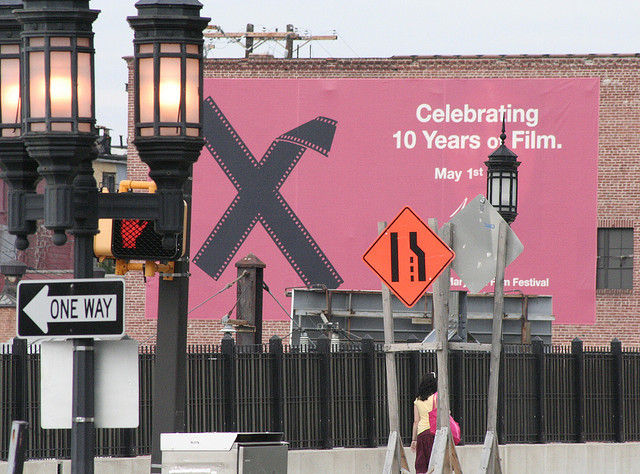<image>What would handicapped people require to park where such a sign is posted? I am not sure what handicapped people require to park where such a sign is posted. It could require handicap plates, placard, disabled parking placard or a sticker. What would handicapped people require to park where such a sign is posted? Handicapped people would require a handicap placard, handicap plates, or a disabled parking placard to park where such a sign is posted. 